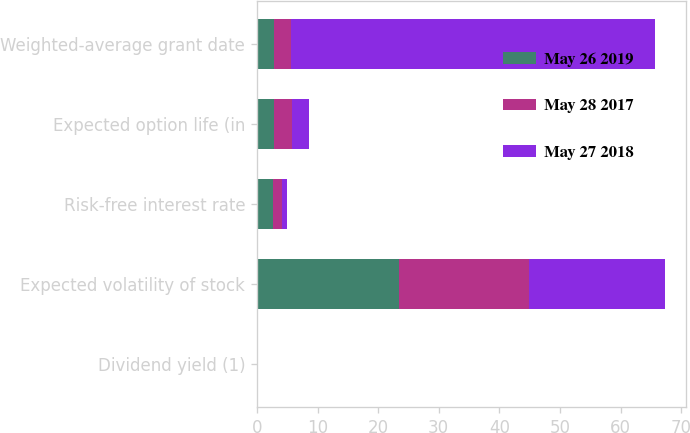<chart> <loc_0><loc_0><loc_500><loc_500><stacked_bar_chart><ecel><fcel>Dividend yield (1)<fcel>Expected volatility of stock<fcel>Risk-free interest rate<fcel>Expected option life (in<fcel>Weighted-average grant date<nl><fcel>May 26 2019<fcel>0<fcel>23.4<fcel>2.7<fcel>2.9<fcel>2.8<nl><fcel>May 28 2017<fcel>0<fcel>21.5<fcel>1.5<fcel>2.9<fcel>2.8<nl><fcel>May 27 2018<fcel>0<fcel>22.5<fcel>0.8<fcel>2.8<fcel>60.05<nl></chart> 